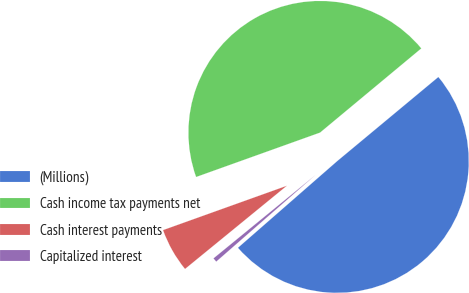<chart> <loc_0><loc_0><loc_500><loc_500><pie_chart><fcel>(Millions)<fcel>Cash income tax payments net<fcel>Cash interest payments<fcel>Capitalized interest<nl><fcel>49.62%<fcel>44.44%<fcel>5.43%<fcel>0.52%<nl></chart> 